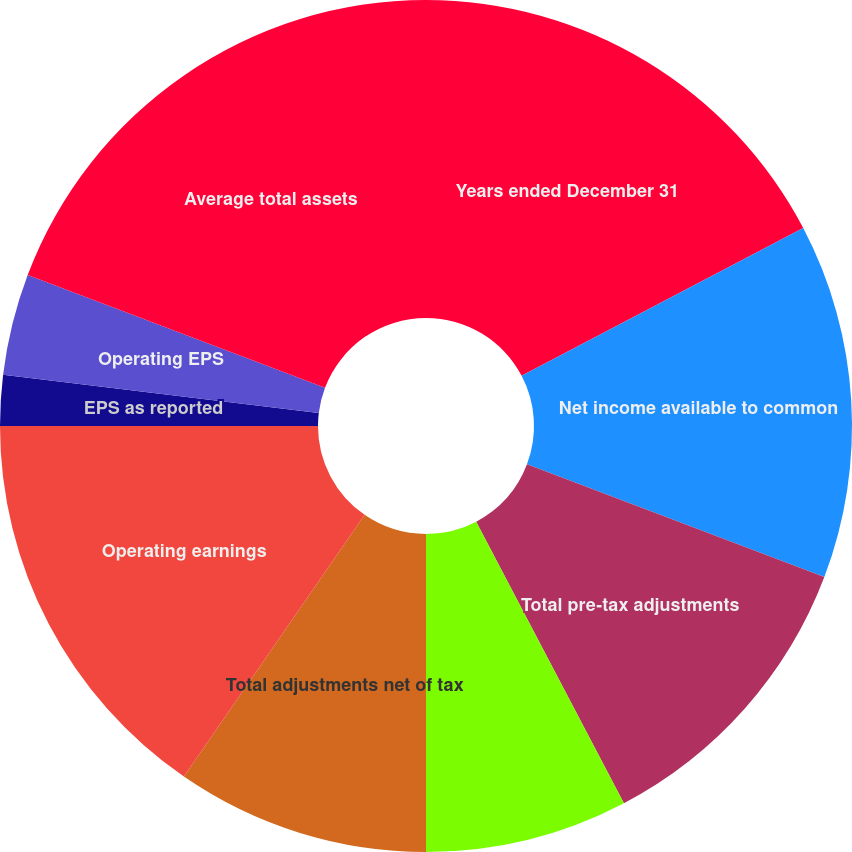<chart> <loc_0><loc_0><loc_500><loc_500><pie_chart><fcel>Years ended December 31<fcel>Net income available to common<fcel>Total pre-tax adjustments<fcel>Tax effect<fcel>Total adjustments net of tax<fcel>Operating earnings<fcel>EPS as reported<fcel>Total adjustments per share<fcel>Operating EPS<fcel>Average total assets<nl><fcel>17.31%<fcel>13.46%<fcel>11.54%<fcel>7.69%<fcel>9.62%<fcel>15.38%<fcel>1.92%<fcel>0.0%<fcel>3.85%<fcel>19.23%<nl></chart> 